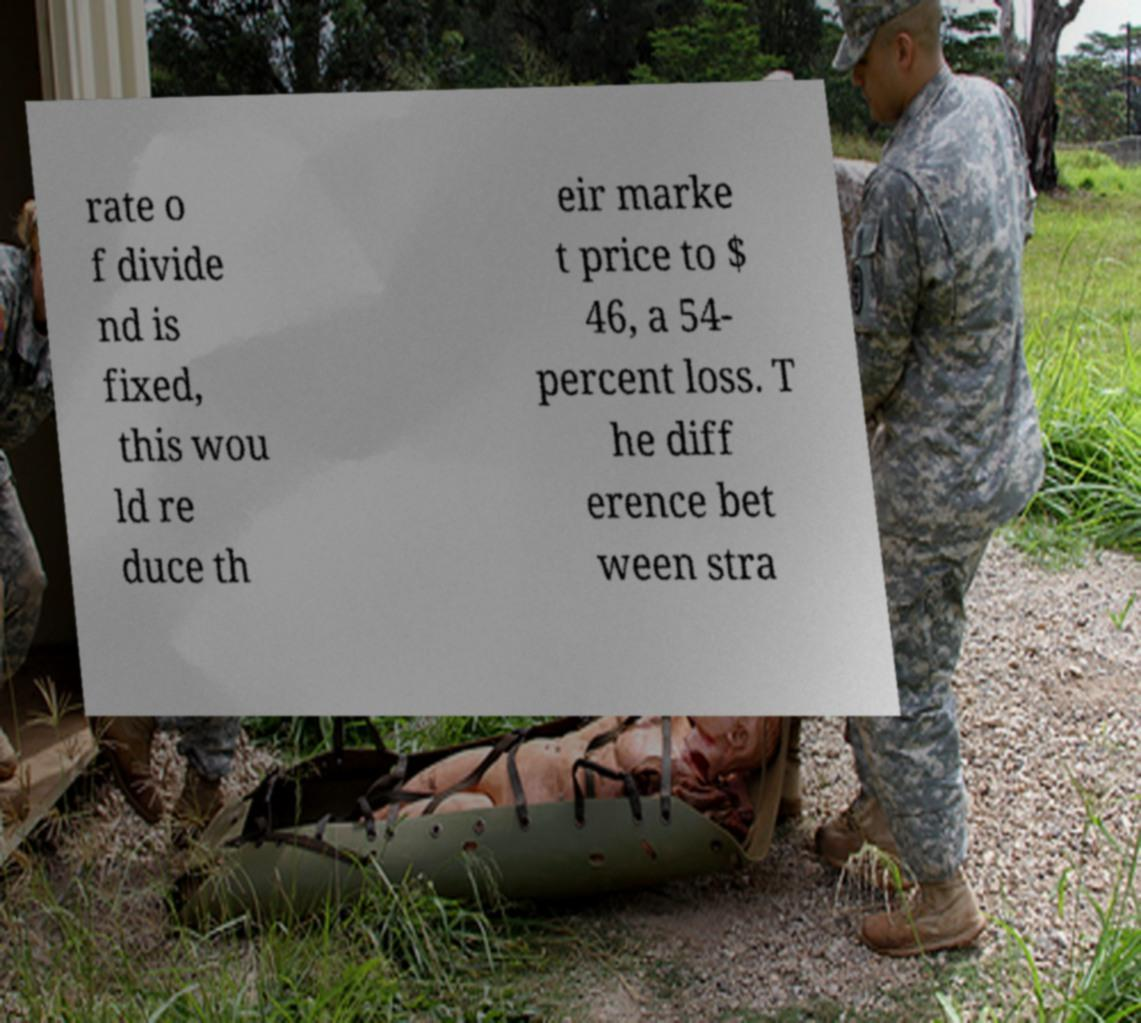What messages or text are displayed in this image? I need them in a readable, typed format. rate o f divide nd is fixed, this wou ld re duce th eir marke t price to $ 46, a 54- percent loss. T he diff erence bet ween stra 